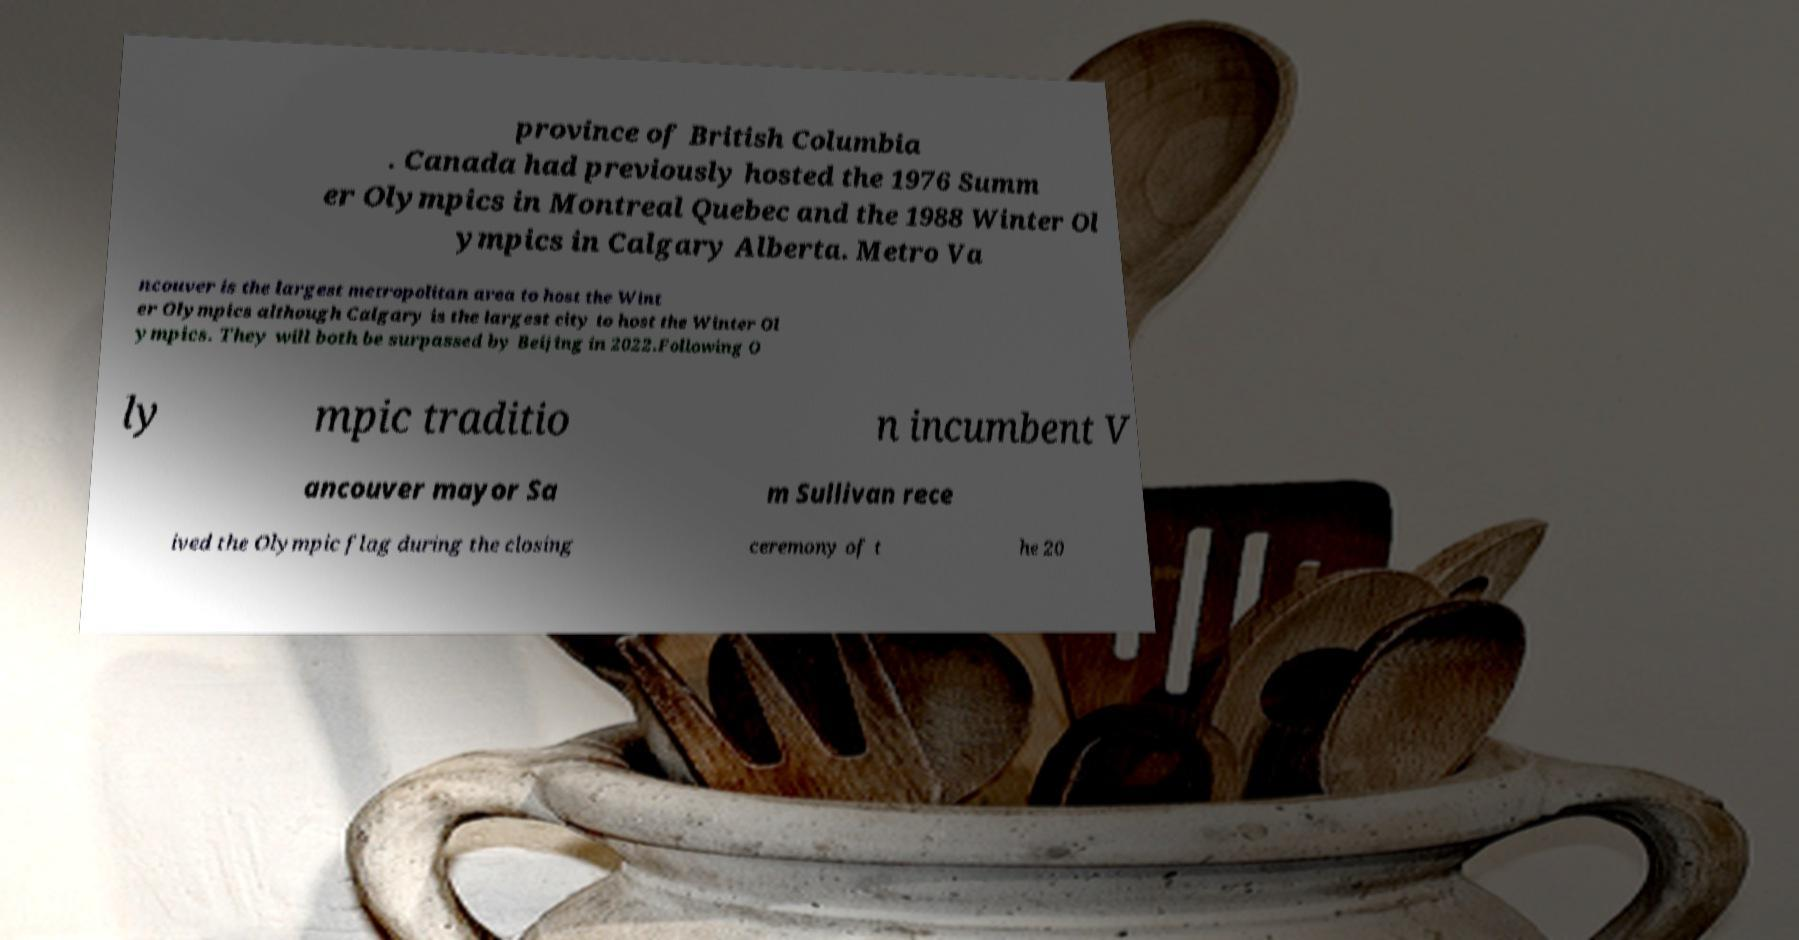Please read and relay the text visible in this image. What does it say? province of British Columbia . Canada had previously hosted the 1976 Summ er Olympics in Montreal Quebec and the 1988 Winter Ol ympics in Calgary Alberta. Metro Va ncouver is the largest metropolitan area to host the Wint er Olympics although Calgary is the largest city to host the Winter Ol ympics. They will both be surpassed by Beijing in 2022.Following O ly mpic traditio n incumbent V ancouver mayor Sa m Sullivan rece ived the Olympic flag during the closing ceremony of t he 20 